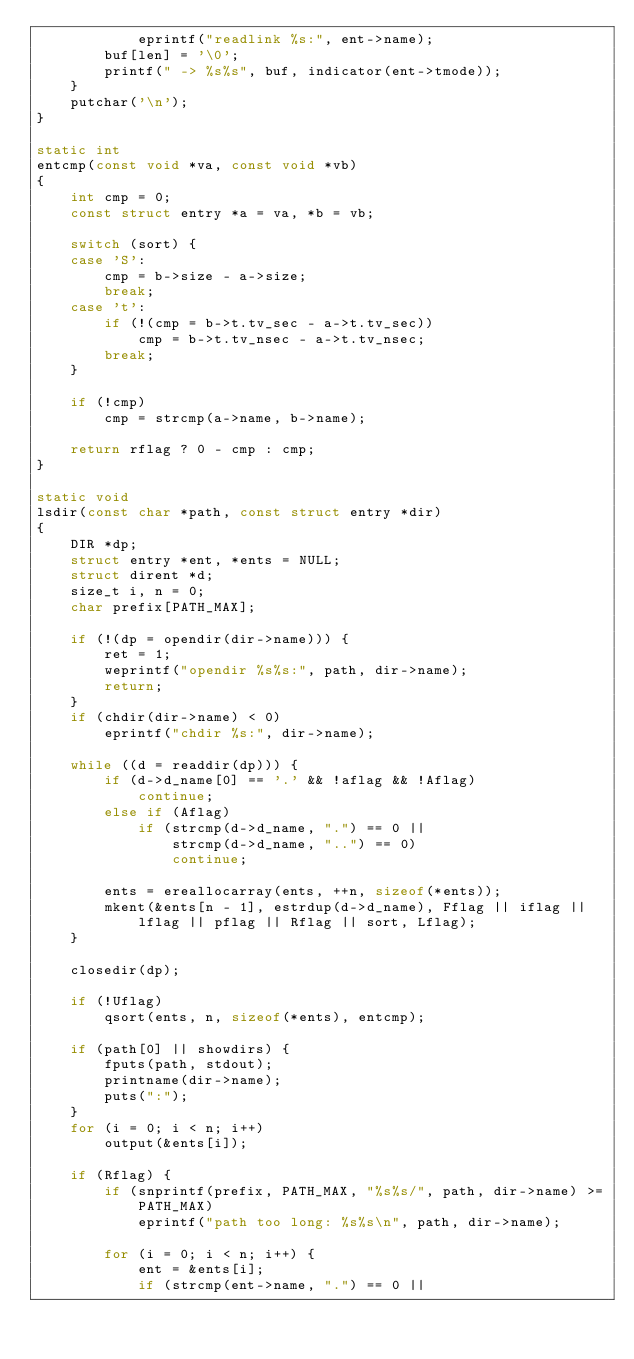<code> <loc_0><loc_0><loc_500><loc_500><_C_>			eprintf("readlink %s:", ent->name);
		buf[len] = '\0';
		printf(" -> %s%s", buf, indicator(ent->tmode));
	}
	putchar('\n');
}

static int
entcmp(const void *va, const void *vb)
{
	int cmp = 0;
	const struct entry *a = va, *b = vb;

	switch (sort) {
	case 'S':
		cmp = b->size - a->size;
		break;
	case 't':
		if (!(cmp = b->t.tv_sec - a->t.tv_sec))
			cmp = b->t.tv_nsec - a->t.tv_nsec;
		break;
	}

	if (!cmp)
		cmp = strcmp(a->name, b->name);

	return rflag ? 0 - cmp : cmp;
}

static void
lsdir(const char *path, const struct entry *dir)
{
	DIR *dp;
	struct entry *ent, *ents = NULL;
	struct dirent *d;
	size_t i, n = 0;
	char prefix[PATH_MAX];

	if (!(dp = opendir(dir->name))) {
		ret = 1;
		weprintf("opendir %s%s:", path, dir->name);
		return;
	}
	if (chdir(dir->name) < 0)
		eprintf("chdir %s:", dir->name);

	while ((d = readdir(dp))) {
		if (d->d_name[0] == '.' && !aflag && !Aflag)
			continue;
		else if (Aflag)
			if (strcmp(d->d_name, ".") == 0 ||
			    strcmp(d->d_name, "..") == 0)
				continue;

		ents = ereallocarray(ents, ++n, sizeof(*ents));
		mkent(&ents[n - 1], estrdup(d->d_name), Fflag || iflag ||
		    lflag || pflag || Rflag || sort, Lflag);
	}

	closedir(dp);

	if (!Uflag)
		qsort(ents, n, sizeof(*ents), entcmp);

	if (path[0] || showdirs) {
		fputs(path, stdout);
		printname(dir->name);
		puts(":");
	}
	for (i = 0; i < n; i++)
		output(&ents[i]);

	if (Rflag) {
		if (snprintf(prefix, PATH_MAX, "%s%s/", path, dir->name) >=
		    PATH_MAX)
			eprintf("path too long: %s%s\n", path, dir->name);

		for (i = 0; i < n; i++) {
			ent = &ents[i];
			if (strcmp(ent->name, ".") == 0 ||</code> 